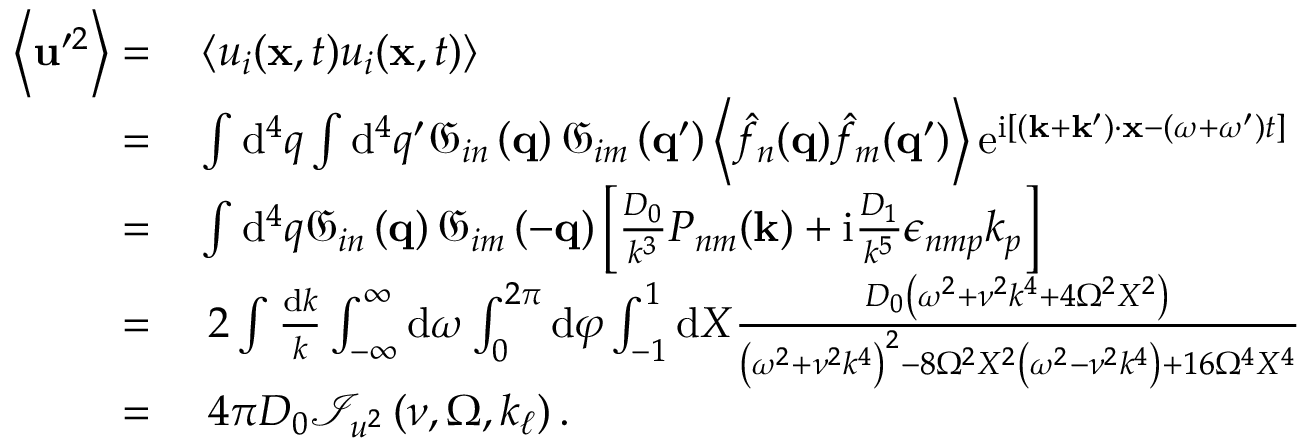<formula> <loc_0><loc_0><loc_500><loc_500>\begin{array} { r l } { \left \langle u ^ { \prime 2 } \right \rangle = } & \left \langle u _ { i } ( x , t ) u _ { i } ( x , t ) \right \rangle } \\ { = } & \int d ^ { 4 } q \int d ^ { 4 } q ^ { \prime } \mathfrak { G } _ { i n } \left ( q \right ) \mathfrak { G } _ { i m } \left ( q ^ { \prime } \right ) \left \langle \hat { f } _ { n } ( q ) \hat { f } _ { m } ( q ^ { \prime } ) \right \rangle e ^ { i \left [ \left ( k + k ^ { \prime } \right ) \cdot x - \left ( \omega + \omega ^ { \prime } \right ) t \right ] } } \\ { = } & \int d ^ { 4 } q \mathfrak { G } _ { i n } \left ( q \right ) \mathfrak { G } _ { i m } \left ( - q \right ) \left [ \frac { D _ { 0 } } { k ^ { 3 } } P _ { n m } ( k ) + i \frac { D _ { 1 } } { k ^ { 5 } } \epsilon _ { n m p } k _ { p } \right ] } \\ { = } & \, 2 \int \frac { d k } { k } \int _ { - \infty } ^ { \infty } d \omega \int _ { 0 } ^ { 2 \pi } d \varphi \int _ { - 1 } ^ { 1 } d X \frac { D _ { 0 } \left ( \omega ^ { 2 } + \nu ^ { 2 } k ^ { 4 } + 4 \Omega ^ { 2 } X ^ { 2 } \right ) } { \left ( \omega ^ { 2 } + \nu ^ { 2 } k ^ { 4 } \right ) ^ { 2 } - 8 \Omega ^ { 2 } X ^ { 2 } \left ( \omega ^ { 2 } - \nu ^ { 2 } k ^ { 4 } \right ) + 1 6 \Omega ^ { 4 } X ^ { 4 } } } \\ { = } & \, 4 \pi D _ { 0 } \mathcal { I } _ { u ^ { 2 } } \left ( \nu , \Omega , k _ { \ell } \right ) . } \end{array}</formula> 